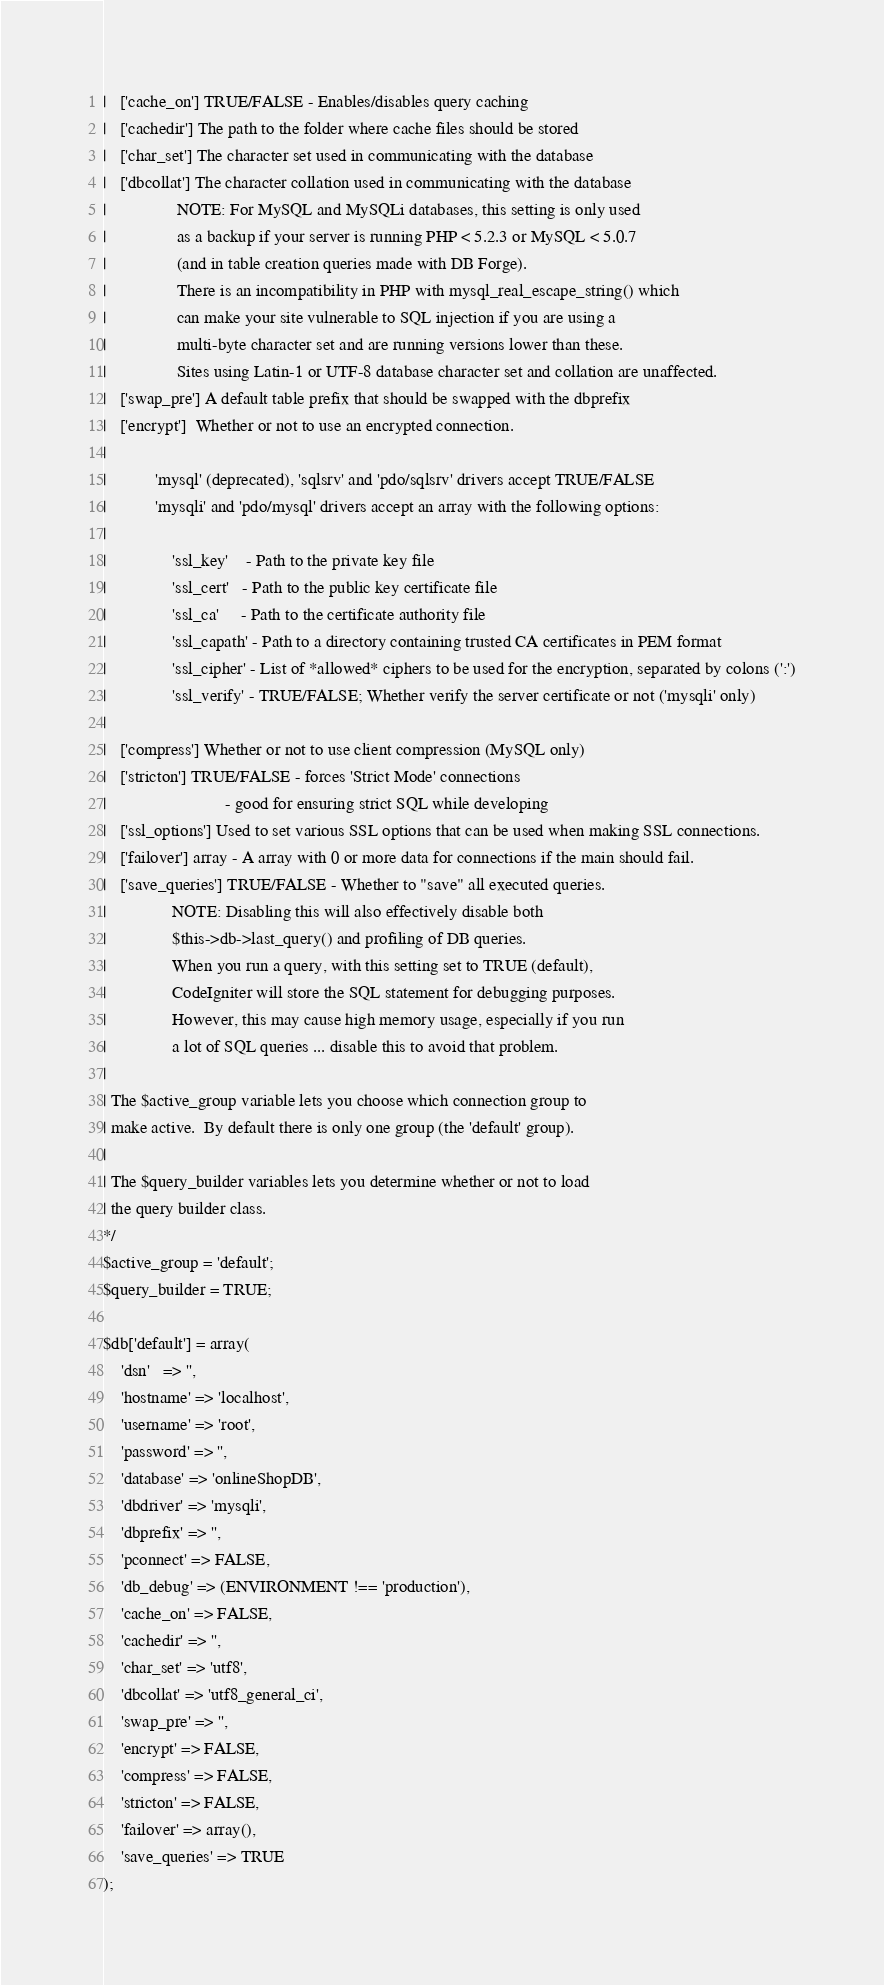Convert code to text. <code><loc_0><loc_0><loc_500><loc_500><_PHP_>|	['cache_on'] TRUE/FALSE - Enables/disables query caching
|	['cachedir'] The path to the folder where cache files should be stored
|	['char_set'] The character set used in communicating with the database
|	['dbcollat'] The character collation used in communicating with the database
|				 NOTE: For MySQL and MySQLi databases, this setting is only used
| 				 as a backup if your server is running PHP < 5.2.3 or MySQL < 5.0.7
|				 (and in table creation queries made with DB Forge).
| 				 There is an incompatibility in PHP with mysql_real_escape_string() which
| 				 can make your site vulnerable to SQL injection if you are using a
| 				 multi-byte character set and are running versions lower than these.
| 				 Sites using Latin-1 or UTF-8 database character set and collation are unaffected.
|	['swap_pre'] A default table prefix that should be swapped with the dbprefix
|	['encrypt']  Whether or not to use an encrypted connection.
|
|			'mysql' (deprecated), 'sqlsrv' and 'pdo/sqlsrv' drivers accept TRUE/FALSE
|			'mysqli' and 'pdo/mysql' drivers accept an array with the following options:
|
|				'ssl_key'    - Path to the private key file
|				'ssl_cert'   - Path to the public key certificate file
|				'ssl_ca'     - Path to the certificate authority file
|				'ssl_capath' - Path to a directory containing trusted CA certificates in PEM format
|				'ssl_cipher' - List of *allowed* ciphers to be used for the encryption, separated by colons (':')
|				'ssl_verify' - TRUE/FALSE; Whether verify the server certificate or not ('mysqli' only)
|
|	['compress'] Whether or not to use client compression (MySQL only)
|	['stricton'] TRUE/FALSE - forces 'Strict Mode' connections
|							- good for ensuring strict SQL while developing
|	['ssl_options']	Used to set various SSL options that can be used when making SSL connections.
|	['failover'] array - A array with 0 or more data for connections if the main should fail.
|	['save_queries'] TRUE/FALSE - Whether to "save" all executed queries.
| 				NOTE: Disabling this will also effectively disable both
| 				$this->db->last_query() and profiling of DB queries.
| 				When you run a query, with this setting set to TRUE (default),
| 				CodeIgniter will store the SQL statement for debugging purposes.
| 				However, this may cause high memory usage, especially if you run
| 				a lot of SQL queries ... disable this to avoid that problem.
|
| The $active_group variable lets you choose which connection group to
| make active.  By default there is only one group (the 'default' group).
|
| The $query_builder variables lets you determine whether or not to load
| the query builder class.
*/
$active_group = 'default';
$query_builder = TRUE;

$db['default'] = array(
	'dsn'	=> '',
	'hostname' => 'localhost',
	'username' => 'root',
	'password' => '',
	'database' => 'onlineShopDB',
	'dbdriver' => 'mysqli',
	'dbprefix' => '',
	'pconnect' => FALSE,
	'db_debug' => (ENVIRONMENT !== 'production'),
	'cache_on' => FALSE,
	'cachedir' => '',
	'char_set' => 'utf8',
	'dbcollat' => 'utf8_general_ci',
	'swap_pre' => '',
	'encrypt' => FALSE,
	'compress' => FALSE,
	'stricton' => FALSE,
	'failover' => array(),
	'save_queries' => TRUE
);
</code> 